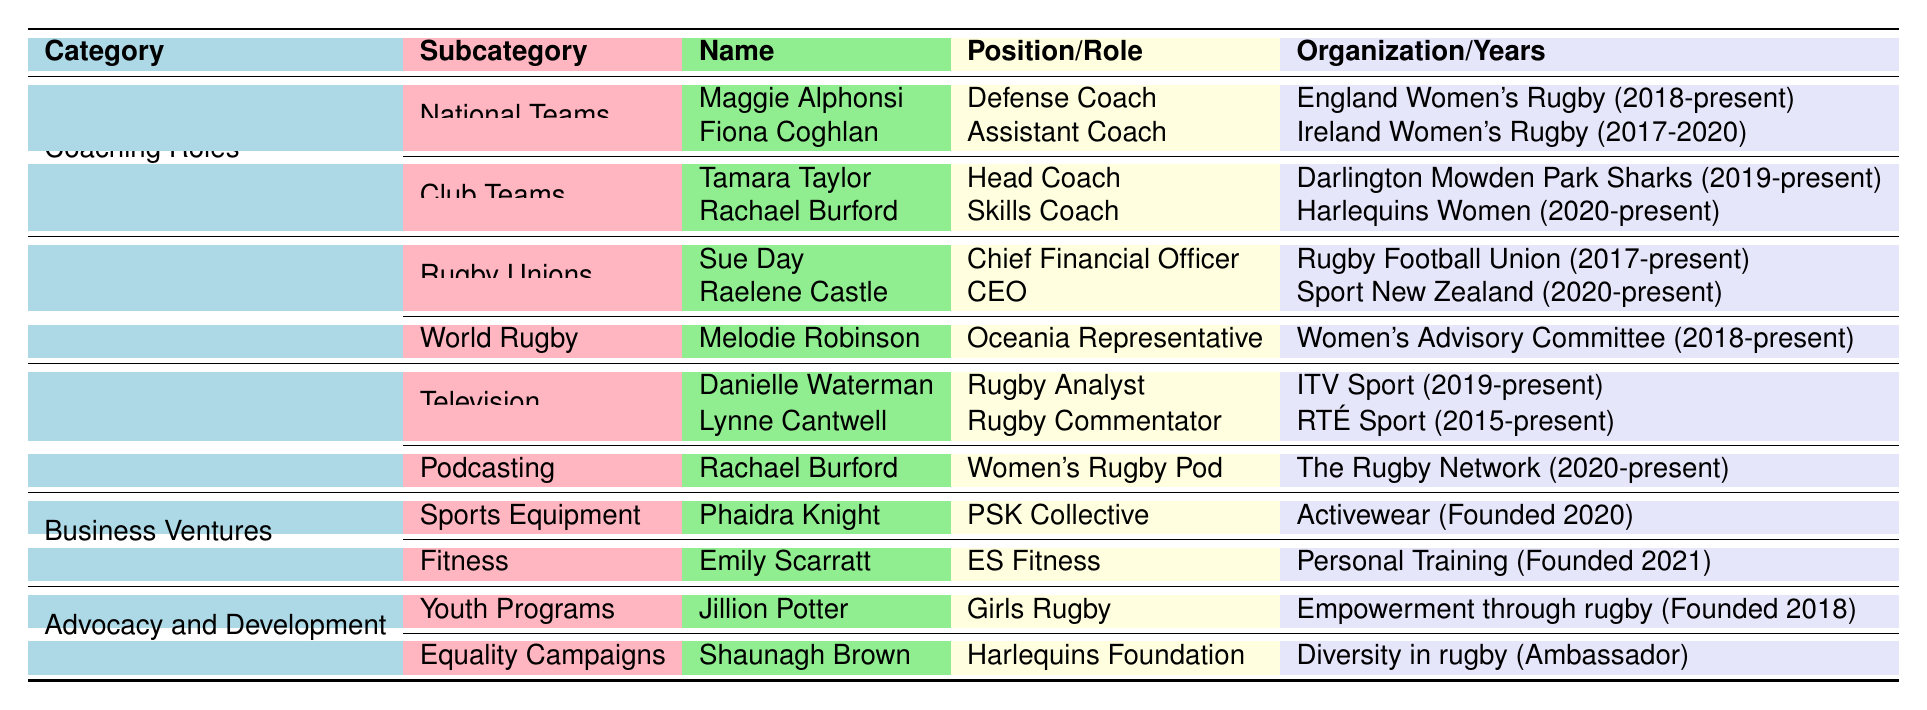What is the position of Maggie Alphonsi? The table lists Maggie Alphonsi under the "National Teams" subcategory of "Coaching Roles," where her position is identified as "Defense Coach."
Answer: Defense Coach Which player served as an Assistant Coach for Ireland Women's Rugby? The table shows that Fiona Coghlan held the position of "Assistant Coach" for Ireland Women's Rugby from 2017 to 2020.
Answer: Fiona Coghlan How many players have coaching roles in club teams? The table indicates there are two players listed under "Coaching Roles" in the "Club Teams" subcategory: Tamara Taylor and Rachael Burford. Thus, the total count is 2.
Answer: 2 Is Emily Scarratt involved in business ventures related to fitness? According to the table, Emily Scarratt is listed under "Business Ventures" in the "Fitness" subcategory, where she provides personal training services. Therefore, the answer is yes.
Answer: Yes What is the total number of roles listed in the "Media and Broadcasting" category? In the "Media and Broadcasting" section, there are three players: Danielle Waterman, Lynne Cantwell, and Rachael Burford. Therefore, the total count of roles is 3.
Answer: 3 What positions does Rachael Burford hold in both coaching and media? The table shows Rachael Burford as a "Skills Coach" for Harlequins Women in coaching and as a host on the "Women's Rugby Pod" for podcasting. Thus, she holds two different positions.
Answer: Skills Coach and Podcast Host Who has founded a fitness business, and what is it called? The table lists Emily Scarratt under "Business Ventures" in the "Fitness" subcategory, where she founded a business called "ES Fitness."
Answer: ES Fitness True or False: Lynne Cantwell has been active in media since 2015. The table includes Lynne Cantwell's role as a Rugby Commentator with RTÉ Sport, specifying her years of activity since 2015, making the statement true.
Answer: True What distinguishes the coaching roles of Tamara Taylor and Maggie Alphonsi? Tamara Taylor is a head coach at a club team (Darlington Mowden Park Sharks), while Maggie Alphonsi is a defense coach for a national team (England Women's Rugby). This highlights their levels and types of teams they coach.
Answer: They coach different levels: Tamara is at a club level, Maggie at a national level Which organization does Raelene Castle lead? The table indicates that Raelene Castle holds the title of CEO of "Sport New Zealand."
Answer: Sport New Zealand 